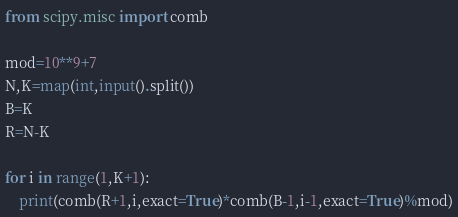Convert code to text. <code><loc_0><loc_0><loc_500><loc_500><_Python_>from scipy.misc import comb

mod=10**9+7
N,K=map(int,input().split())
B=K
R=N-K

for i in range(1,K+1):
    print(comb(R+1,i,exact=True)*comb(B-1,i-1,exact=True)%mod)</code> 